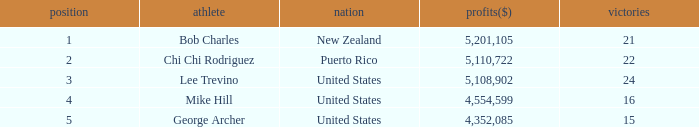On average, how many wins have a rank lower than 1? None. 